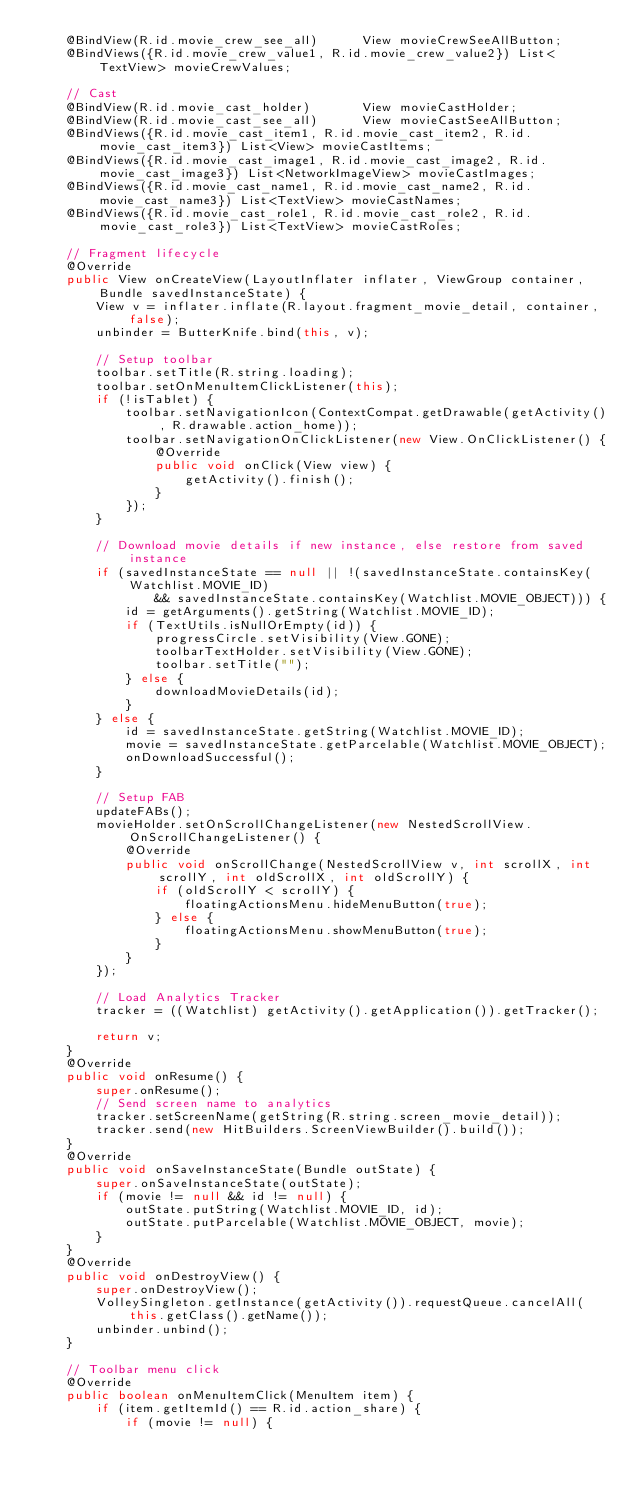Convert code to text. <code><loc_0><loc_0><loc_500><loc_500><_Java_>    @BindView(R.id.movie_crew_see_all)      View movieCrewSeeAllButton;
    @BindViews({R.id.movie_crew_value1, R.id.movie_crew_value2}) List<TextView> movieCrewValues;

    // Cast
    @BindView(R.id.movie_cast_holder)       View movieCastHolder;
    @BindView(R.id.movie_cast_see_all)      View movieCastSeeAllButton;
    @BindViews({R.id.movie_cast_item1, R.id.movie_cast_item2, R.id.movie_cast_item3}) List<View> movieCastItems;
    @BindViews({R.id.movie_cast_image1, R.id.movie_cast_image2, R.id.movie_cast_image3}) List<NetworkImageView> movieCastImages;
    @BindViews({R.id.movie_cast_name1, R.id.movie_cast_name2, R.id.movie_cast_name3}) List<TextView> movieCastNames;
    @BindViews({R.id.movie_cast_role1, R.id.movie_cast_role2, R.id.movie_cast_role3}) List<TextView> movieCastRoles;

    // Fragment lifecycle
    @Override
    public View onCreateView(LayoutInflater inflater, ViewGroup container, Bundle savedInstanceState) {
        View v = inflater.inflate(R.layout.fragment_movie_detail, container, false);
        unbinder = ButterKnife.bind(this, v);

        // Setup toolbar
        toolbar.setTitle(R.string.loading);
        toolbar.setOnMenuItemClickListener(this);
        if (!isTablet) {
            toolbar.setNavigationIcon(ContextCompat.getDrawable(getActivity(), R.drawable.action_home));
            toolbar.setNavigationOnClickListener(new View.OnClickListener() {
                @Override
                public void onClick(View view) {
                    getActivity().finish();
                }
            });
        }

        // Download movie details if new instance, else restore from saved instance
        if (savedInstanceState == null || !(savedInstanceState.containsKey(Watchlist.MOVIE_ID)
                && savedInstanceState.containsKey(Watchlist.MOVIE_OBJECT))) {
            id = getArguments().getString(Watchlist.MOVIE_ID);
            if (TextUtils.isNullOrEmpty(id)) {
                progressCircle.setVisibility(View.GONE);
                toolbarTextHolder.setVisibility(View.GONE);
                toolbar.setTitle("");
            } else {
                downloadMovieDetails(id);
            }
        } else {
            id = savedInstanceState.getString(Watchlist.MOVIE_ID);
            movie = savedInstanceState.getParcelable(Watchlist.MOVIE_OBJECT);
            onDownloadSuccessful();
        }

        // Setup FAB
        updateFABs();
        movieHolder.setOnScrollChangeListener(new NestedScrollView.OnScrollChangeListener() {
            @Override
            public void onScrollChange(NestedScrollView v, int scrollX, int scrollY, int oldScrollX, int oldScrollY) {
                if (oldScrollY < scrollY) {
                    floatingActionsMenu.hideMenuButton(true);
                } else {
                    floatingActionsMenu.showMenuButton(true);
                }
            }
        });

        // Load Analytics Tracker
        tracker = ((Watchlist) getActivity().getApplication()).getTracker();

        return v;
    }
    @Override
    public void onResume() {
        super.onResume();
        // Send screen name to analytics
        tracker.setScreenName(getString(R.string.screen_movie_detail));
        tracker.send(new HitBuilders.ScreenViewBuilder().build());
    }
    @Override
    public void onSaveInstanceState(Bundle outState) {
        super.onSaveInstanceState(outState);
        if (movie != null && id != null) {
            outState.putString(Watchlist.MOVIE_ID, id);
            outState.putParcelable(Watchlist.MOVIE_OBJECT, movie);
        }
    }
    @Override
    public void onDestroyView() {
        super.onDestroyView();
        VolleySingleton.getInstance(getActivity()).requestQueue.cancelAll(this.getClass().getName());
        unbinder.unbind();
    }

    // Toolbar menu click
    @Override
    public boolean onMenuItemClick(MenuItem item) {
        if (item.getItemId() == R.id.action_share) {
            if (movie != null) {</code> 